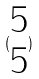Convert formula to latex. <formula><loc_0><loc_0><loc_500><loc_500>( \begin{matrix} 5 \\ 5 \end{matrix} )</formula> 